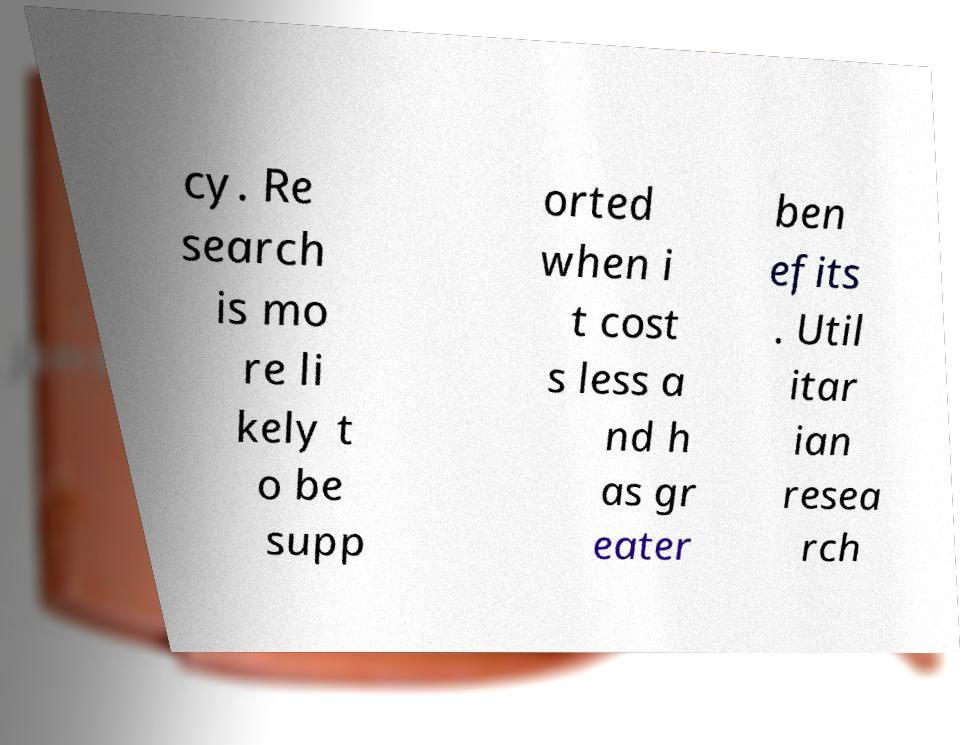Can you read and provide the text displayed in the image?This photo seems to have some interesting text. Can you extract and type it out for me? cy. Re search is mo re li kely t o be supp orted when i t cost s less a nd h as gr eater ben efits . Util itar ian resea rch 